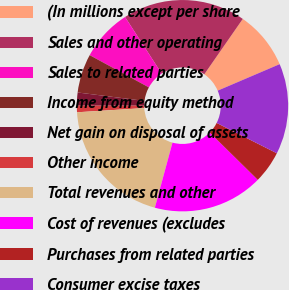<chart> <loc_0><loc_0><loc_500><loc_500><pie_chart><fcel>(In millions except per share<fcel>Sales and other operating<fcel>Sales to related parties<fcel>Income from equity method<fcel>Net gain on disposal of assets<fcel>Other income<fcel>Total revenues and other<fcel>Cost of revenues (excludes<fcel>Purchases from related parties<fcel>Consumer excise taxes<nl><fcel>8.91%<fcel>18.81%<fcel>7.92%<fcel>5.94%<fcel>1.99%<fcel>1.0%<fcel>19.8%<fcel>16.83%<fcel>4.95%<fcel>13.86%<nl></chart> 